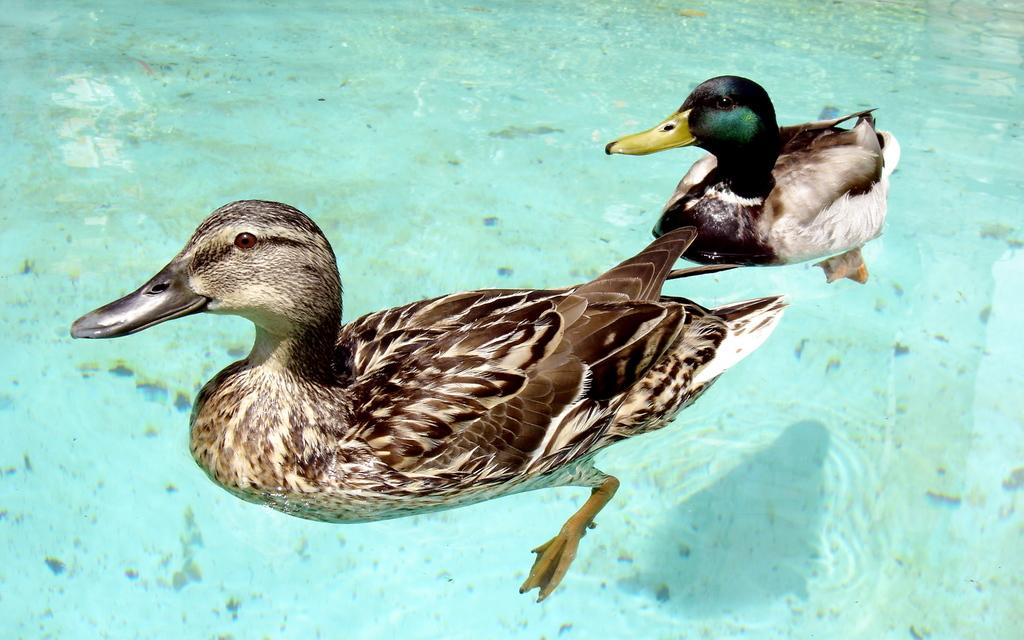How many birds are in the image? There are two birds in the image. What colors can be seen on the birds? The birds have brown, white, and black coloring. What is visible in the image besides the birds? There is water visible in the image. What type of steel is being used to pull the birds in the image? There is no steel or pulling action involving the birds in the image; they are simply perched or swimming in the water. 